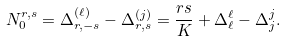Convert formula to latex. <formula><loc_0><loc_0><loc_500><loc_500>N _ { 0 } ^ { r , s } = \Delta _ { r , - s } ^ { ( \ell ) } - \Delta _ { r , s } ^ { ( j ) } = \frac { r s } { K } + \Delta _ { \ell } ^ { \ell } - \Delta _ { j } ^ { j } .</formula> 